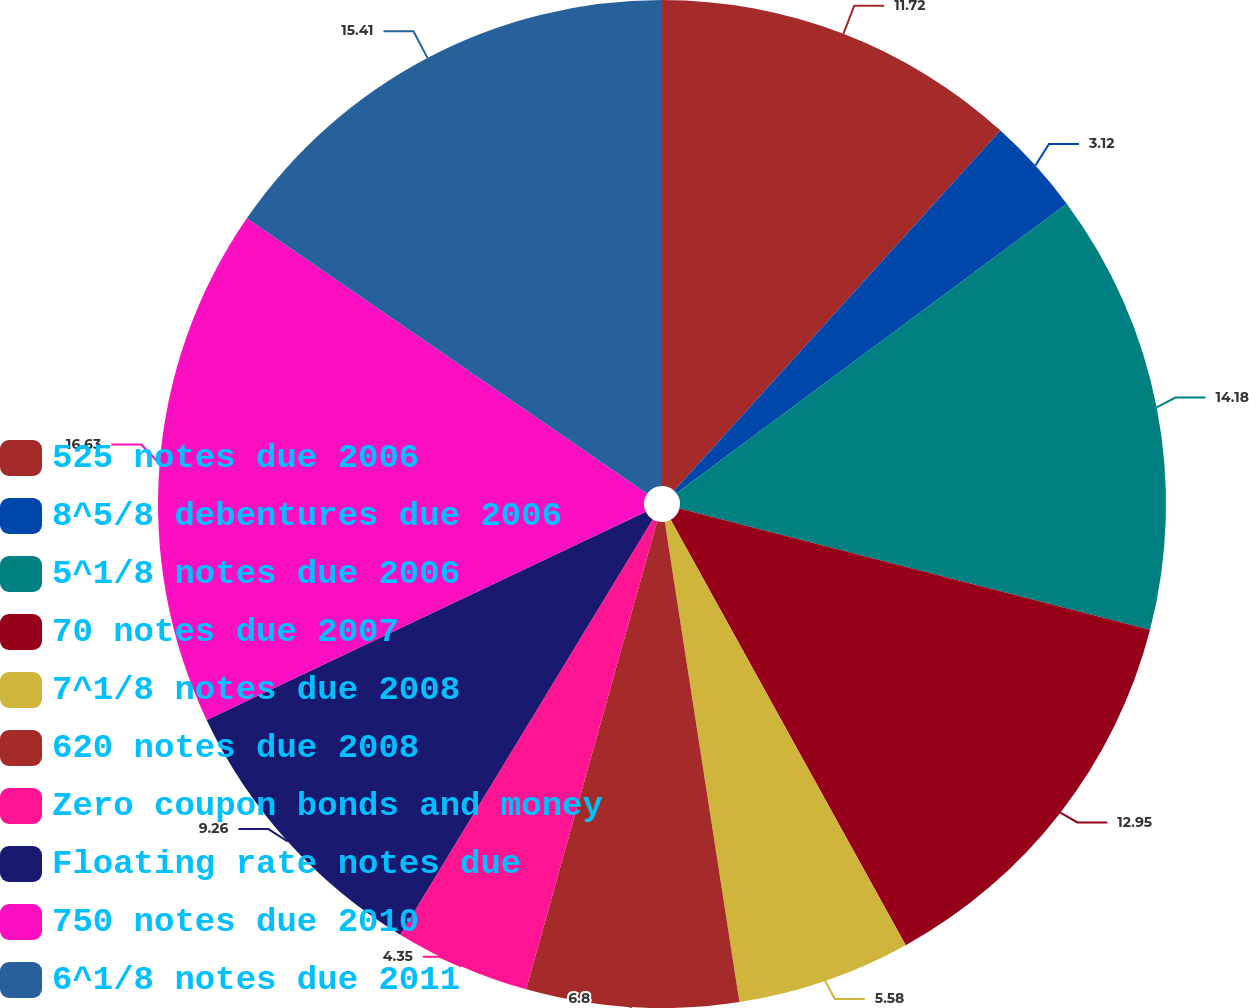Convert chart. <chart><loc_0><loc_0><loc_500><loc_500><pie_chart><fcel>525 notes due 2006<fcel>8^5/8 debentures due 2006<fcel>5^1/8 notes due 2006<fcel>70 notes due 2007<fcel>7^1/8 notes due 2008<fcel>620 notes due 2008<fcel>Zero coupon bonds and money<fcel>Floating rate notes due<fcel>750 notes due 2010<fcel>6^1/8 notes due 2011<nl><fcel>11.72%<fcel>3.12%<fcel>14.18%<fcel>12.95%<fcel>5.58%<fcel>6.8%<fcel>4.35%<fcel>9.26%<fcel>16.64%<fcel>15.41%<nl></chart> 